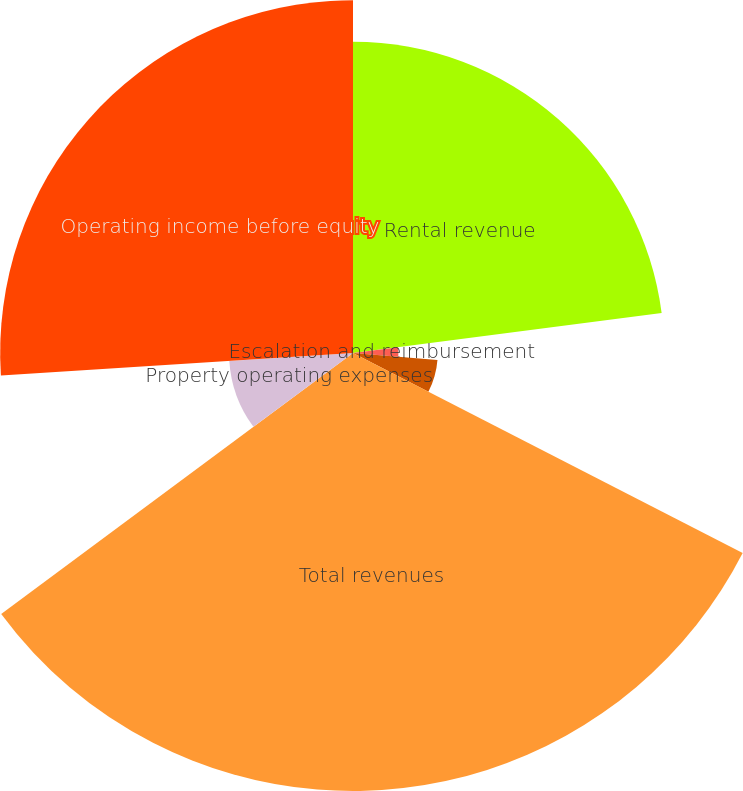Convert chart. <chart><loc_0><loc_0><loc_500><loc_500><pie_chart><fcel>Rental revenue<fcel>Escalation and reimbursement<fcel>Other income<fcel>Total revenues<fcel>Property operating expenses<fcel>Operating income before equity<nl><fcel>22.95%<fcel>3.35%<fcel>6.25%<fcel>32.3%<fcel>9.14%<fcel>26.02%<nl></chart> 